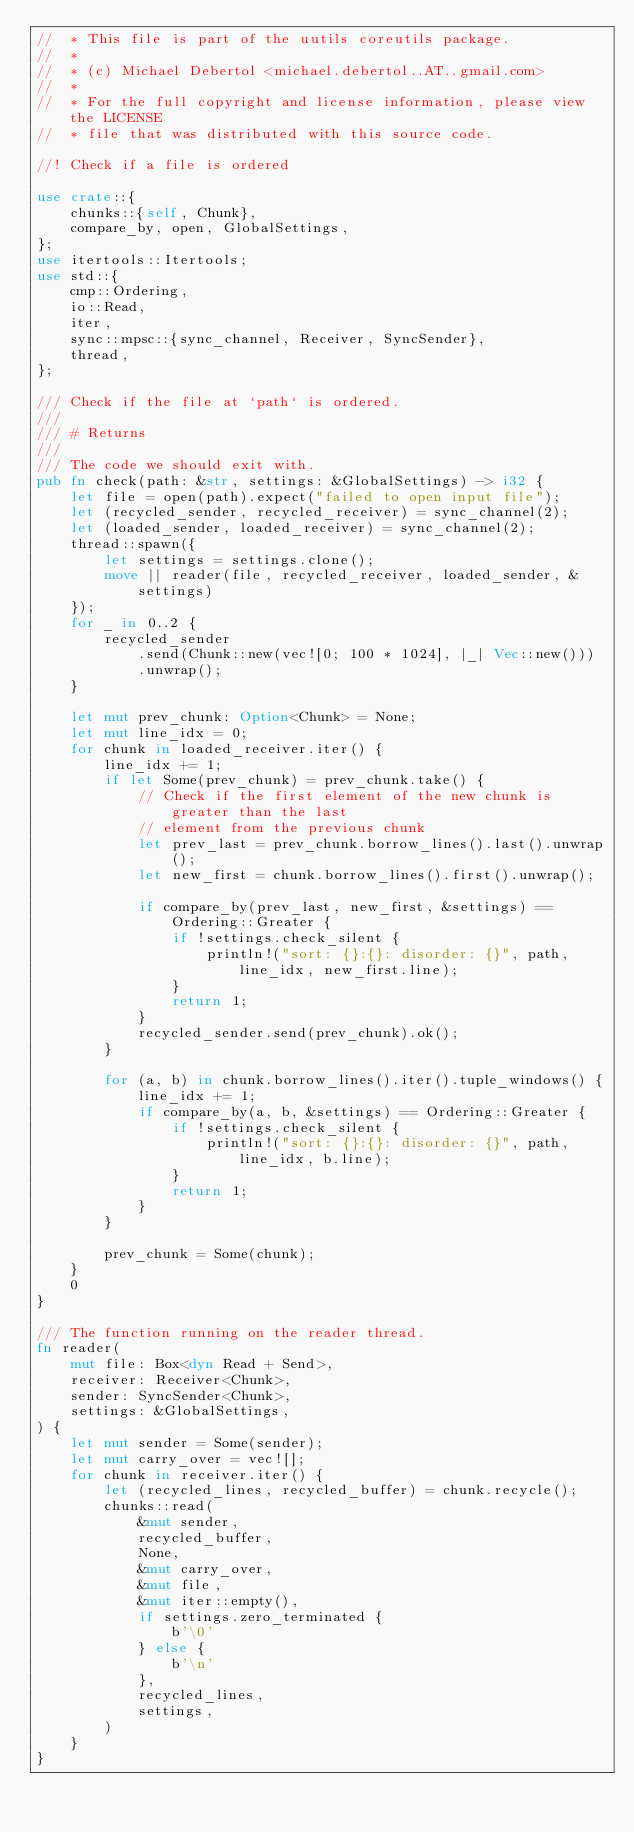<code> <loc_0><loc_0><loc_500><loc_500><_Rust_>//  * This file is part of the uutils coreutils package.
//  *
//  * (c) Michael Debertol <michael.debertol..AT..gmail.com>
//  *
//  * For the full copyright and license information, please view the LICENSE
//  * file that was distributed with this source code.

//! Check if a file is ordered

use crate::{
    chunks::{self, Chunk},
    compare_by, open, GlobalSettings,
};
use itertools::Itertools;
use std::{
    cmp::Ordering,
    io::Read,
    iter,
    sync::mpsc::{sync_channel, Receiver, SyncSender},
    thread,
};

/// Check if the file at `path` is ordered.
///
/// # Returns
///
/// The code we should exit with.
pub fn check(path: &str, settings: &GlobalSettings) -> i32 {
    let file = open(path).expect("failed to open input file");
    let (recycled_sender, recycled_receiver) = sync_channel(2);
    let (loaded_sender, loaded_receiver) = sync_channel(2);
    thread::spawn({
        let settings = settings.clone();
        move || reader(file, recycled_receiver, loaded_sender, &settings)
    });
    for _ in 0..2 {
        recycled_sender
            .send(Chunk::new(vec![0; 100 * 1024], |_| Vec::new()))
            .unwrap();
    }

    let mut prev_chunk: Option<Chunk> = None;
    let mut line_idx = 0;
    for chunk in loaded_receiver.iter() {
        line_idx += 1;
        if let Some(prev_chunk) = prev_chunk.take() {
            // Check if the first element of the new chunk is greater than the last
            // element from the previous chunk
            let prev_last = prev_chunk.borrow_lines().last().unwrap();
            let new_first = chunk.borrow_lines().first().unwrap();

            if compare_by(prev_last, new_first, &settings) == Ordering::Greater {
                if !settings.check_silent {
                    println!("sort: {}:{}: disorder: {}", path, line_idx, new_first.line);
                }
                return 1;
            }
            recycled_sender.send(prev_chunk).ok();
        }

        for (a, b) in chunk.borrow_lines().iter().tuple_windows() {
            line_idx += 1;
            if compare_by(a, b, &settings) == Ordering::Greater {
                if !settings.check_silent {
                    println!("sort: {}:{}: disorder: {}", path, line_idx, b.line);
                }
                return 1;
            }
        }

        prev_chunk = Some(chunk);
    }
    0
}

/// The function running on the reader thread.
fn reader(
    mut file: Box<dyn Read + Send>,
    receiver: Receiver<Chunk>,
    sender: SyncSender<Chunk>,
    settings: &GlobalSettings,
) {
    let mut sender = Some(sender);
    let mut carry_over = vec![];
    for chunk in receiver.iter() {
        let (recycled_lines, recycled_buffer) = chunk.recycle();
        chunks::read(
            &mut sender,
            recycled_buffer,
            None,
            &mut carry_over,
            &mut file,
            &mut iter::empty(),
            if settings.zero_terminated {
                b'\0'
            } else {
                b'\n'
            },
            recycled_lines,
            settings,
        )
    }
}
</code> 